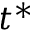Convert formula to latex. <formula><loc_0><loc_0><loc_500><loc_500>t ^ { * }</formula> 